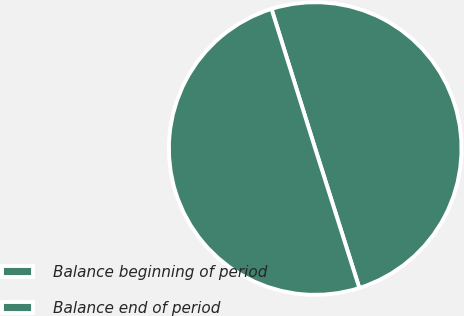<chart> <loc_0><loc_0><loc_500><loc_500><pie_chart><fcel>Balance beginning of period<fcel>Balance end of period<nl><fcel>49.95%<fcel>50.05%<nl></chart> 